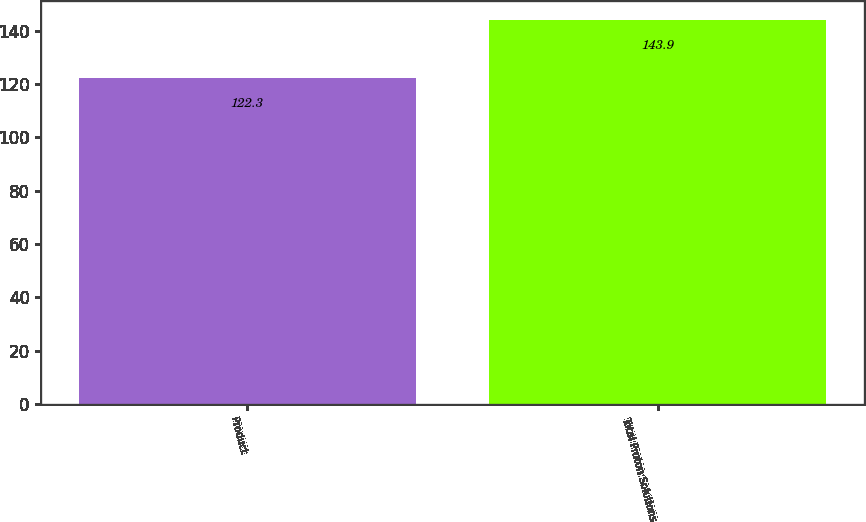<chart> <loc_0><loc_0><loc_500><loc_500><bar_chart><fcel>Product<fcel>Total Proton Solutions<nl><fcel>122.3<fcel>143.9<nl></chart> 